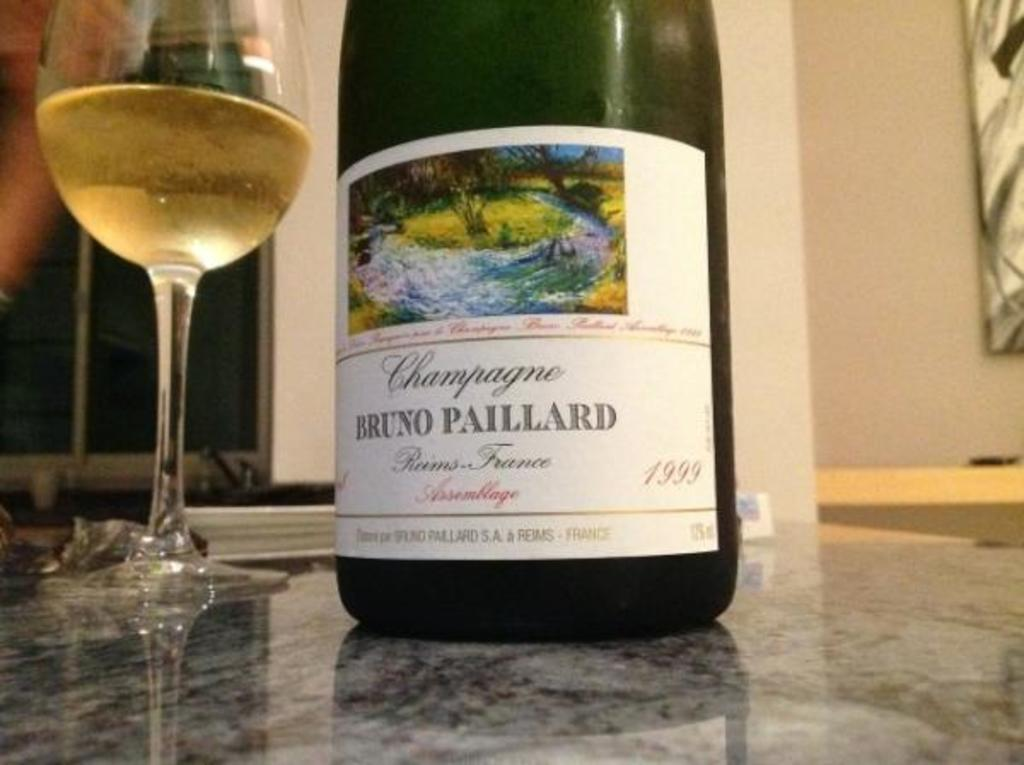<image>
Relay a brief, clear account of the picture shown. A Bruno Paillard bottle of wine is next to a poured glass of wine. 